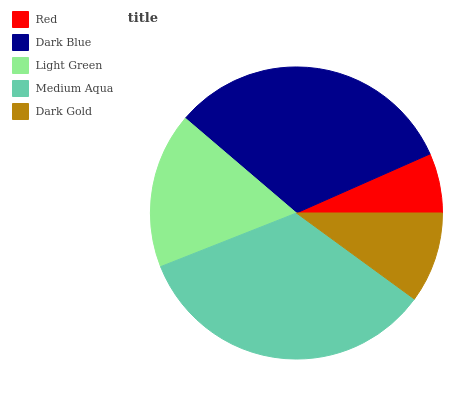Is Red the minimum?
Answer yes or no. Yes. Is Medium Aqua the maximum?
Answer yes or no. Yes. Is Dark Blue the minimum?
Answer yes or no. No. Is Dark Blue the maximum?
Answer yes or no. No. Is Dark Blue greater than Red?
Answer yes or no. Yes. Is Red less than Dark Blue?
Answer yes or no. Yes. Is Red greater than Dark Blue?
Answer yes or no. No. Is Dark Blue less than Red?
Answer yes or no. No. Is Light Green the high median?
Answer yes or no. Yes. Is Light Green the low median?
Answer yes or no. Yes. Is Red the high median?
Answer yes or no. No. Is Red the low median?
Answer yes or no. No. 